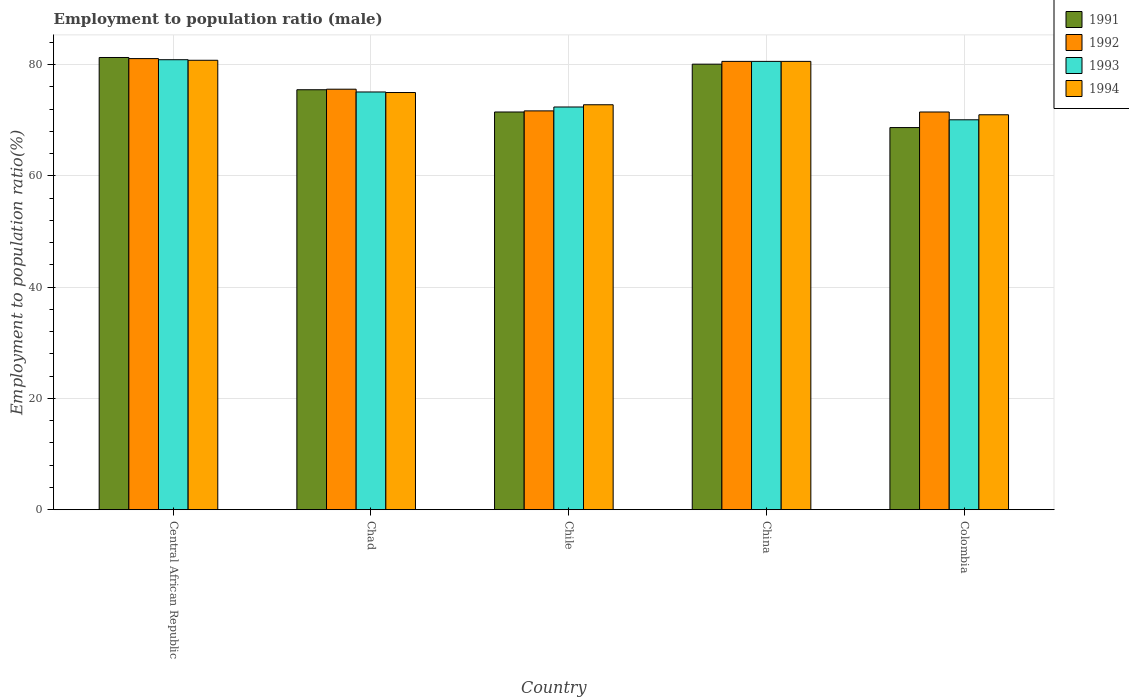Are the number of bars on each tick of the X-axis equal?
Your answer should be compact. Yes. What is the label of the 3rd group of bars from the left?
Your answer should be very brief. Chile. What is the employment to population ratio in 1993 in Central African Republic?
Your answer should be very brief. 80.9. Across all countries, what is the maximum employment to population ratio in 1991?
Make the answer very short. 81.3. Across all countries, what is the minimum employment to population ratio in 1994?
Give a very brief answer. 71. In which country was the employment to population ratio in 1993 maximum?
Your response must be concise. Central African Republic. What is the total employment to population ratio in 1994 in the graph?
Offer a terse response. 380.2. What is the difference between the employment to population ratio in 1994 in Chad and that in Colombia?
Provide a short and direct response. 4. What is the difference between the employment to population ratio in 1994 in Chile and the employment to population ratio in 1992 in Chad?
Your answer should be compact. -2.8. What is the average employment to population ratio in 1994 per country?
Offer a terse response. 76.04. What is the difference between the employment to population ratio of/in 1991 and employment to population ratio of/in 1994 in Chile?
Make the answer very short. -1.3. In how many countries, is the employment to population ratio in 1993 greater than 44 %?
Your answer should be compact. 5. What is the ratio of the employment to population ratio in 1994 in Chile to that in China?
Your answer should be compact. 0.9. Is the employment to population ratio in 1993 in Chad less than that in Colombia?
Make the answer very short. No. Is the difference between the employment to population ratio in 1991 in China and Colombia greater than the difference between the employment to population ratio in 1994 in China and Colombia?
Provide a short and direct response. Yes. What is the difference between the highest and the lowest employment to population ratio in 1993?
Your answer should be compact. 10.8. What does the 1st bar from the left in Colombia represents?
Ensure brevity in your answer.  1991. What does the 3rd bar from the right in Chile represents?
Offer a terse response. 1992. Is it the case that in every country, the sum of the employment to population ratio in 1991 and employment to population ratio in 1994 is greater than the employment to population ratio in 1993?
Provide a short and direct response. Yes. Are the values on the major ticks of Y-axis written in scientific E-notation?
Your response must be concise. No. Does the graph contain grids?
Your answer should be compact. Yes. How many legend labels are there?
Offer a terse response. 4. How are the legend labels stacked?
Offer a terse response. Vertical. What is the title of the graph?
Offer a very short reply. Employment to population ratio (male). Does "1994" appear as one of the legend labels in the graph?
Offer a terse response. Yes. What is the Employment to population ratio(%) of 1991 in Central African Republic?
Ensure brevity in your answer.  81.3. What is the Employment to population ratio(%) in 1992 in Central African Republic?
Offer a terse response. 81.1. What is the Employment to population ratio(%) of 1993 in Central African Republic?
Your response must be concise. 80.9. What is the Employment to population ratio(%) of 1994 in Central African Republic?
Your response must be concise. 80.8. What is the Employment to population ratio(%) of 1991 in Chad?
Provide a short and direct response. 75.5. What is the Employment to population ratio(%) in 1992 in Chad?
Ensure brevity in your answer.  75.6. What is the Employment to population ratio(%) of 1993 in Chad?
Give a very brief answer. 75.1. What is the Employment to population ratio(%) in 1994 in Chad?
Offer a terse response. 75. What is the Employment to population ratio(%) of 1991 in Chile?
Your response must be concise. 71.5. What is the Employment to population ratio(%) in 1992 in Chile?
Offer a very short reply. 71.7. What is the Employment to population ratio(%) in 1993 in Chile?
Offer a very short reply. 72.4. What is the Employment to population ratio(%) of 1994 in Chile?
Ensure brevity in your answer.  72.8. What is the Employment to population ratio(%) in 1991 in China?
Offer a very short reply. 80.1. What is the Employment to population ratio(%) of 1992 in China?
Your answer should be very brief. 80.6. What is the Employment to population ratio(%) of 1993 in China?
Your answer should be compact. 80.6. What is the Employment to population ratio(%) of 1994 in China?
Ensure brevity in your answer.  80.6. What is the Employment to population ratio(%) in 1991 in Colombia?
Your response must be concise. 68.7. What is the Employment to population ratio(%) of 1992 in Colombia?
Your response must be concise. 71.5. What is the Employment to population ratio(%) of 1993 in Colombia?
Make the answer very short. 70.1. What is the Employment to population ratio(%) in 1994 in Colombia?
Ensure brevity in your answer.  71. Across all countries, what is the maximum Employment to population ratio(%) of 1991?
Make the answer very short. 81.3. Across all countries, what is the maximum Employment to population ratio(%) of 1992?
Provide a short and direct response. 81.1. Across all countries, what is the maximum Employment to population ratio(%) in 1993?
Keep it short and to the point. 80.9. Across all countries, what is the maximum Employment to population ratio(%) of 1994?
Ensure brevity in your answer.  80.8. Across all countries, what is the minimum Employment to population ratio(%) in 1991?
Offer a very short reply. 68.7. Across all countries, what is the minimum Employment to population ratio(%) of 1992?
Your answer should be very brief. 71.5. Across all countries, what is the minimum Employment to population ratio(%) of 1993?
Provide a short and direct response. 70.1. Across all countries, what is the minimum Employment to population ratio(%) of 1994?
Your response must be concise. 71. What is the total Employment to population ratio(%) of 1991 in the graph?
Make the answer very short. 377.1. What is the total Employment to population ratio(%) in 1992 in the graph?
Give a very brief answer. 380.5. What is the total Employment to population ratio(%) in 1993 in the graph?
Make the answer very short. 379.1. What is the total Employment to population ratio(%) in 1994 in the graph?
Provide a succinct answer. 380.2. What is the difference between the Employment to population ratio(%) of 1994 in Central African Republic and that in Chad?
Offer a very short reply. 5.8. What is the difference between the Employment to population ratio(%) of 1991 in Central African Republic and that in Chile?
Your answer should be very brief. 9.8. What is the difference between the Employment to population ratio(%) of 1992 in Central African Republic and that in Chile?
Offer a very short reply. 9.4. What is the difference between the Employment to population ratio(%) of 1993 in Central African Republic and that in Chile?
Offer a very short reply. 8.5. What is the difference between the Employment to population ratio(%) in 1991 in Central African Republic and that in China?
Your answer should be very brief. 1.2. What is the difference between the Employment to population ratio(%) of 1991 in Central African Republic and that in Colombia?
Provide a short and direct response. 12.6. What is the difference between the Employment to population ratio(%) in 1994 in Central African Republic and that in Colombia?
Offer a terse response. 9.8. What is the difference between the Employment to population ratio(%) of 1991 in Chad and that in Chile?
Make the answer very short. 4. What is the difference between the Employment to population ratio(%) of 1992 in Chad and that in Chile?
Ensure brevity in your answer.  3.9. What is the difference between the Employment to population ratio(%) in 1991 in Chad and that in China?
Give a very brief answer. -4.6. What is the difference between the Employment to population ratio(%) in 1992 in Chad and that in China?
Your answer should be very brief. -5. What is the difference between the Employment to population ratio(%) of 1991 in Chad and that in Colombia?
Ensure brevity in your answer.  6.8. What is the difference between the Employment to population ratio(%) in 1994 in Chad and that in Colombia?
Provide a short and direct response. 4. What is the difference between the Employment to population ratio(%) of 1991 in Chile and that in China?
Your response must be concise. -8.6. What is the difference between the Employment to population ratio(%) of 1992 in Chile and that in China?
Offer a very short reply. -8.9. What is the difference between the Employment to population ratio(%) of 1993 in Chile and that in China?
Your response must be concise. -8.2. What is the difference between the Employment to population ratio(%) of 1992 in Chile and that in Colombia?
Provide a succinct answer. 0.2. What is the difference between the Employment to population ratio(%) in 1994 in Chile and that in Colombia?
Your answer should be compact. 1.8. What is the difference between the Employment to population ratio(%) in 1991 in China and that in Colombia?
Your response must be concise. 11.4. What is the difference between the Employment to population ratio(%) in 1993 in China and that in Colombia?
Provide a short and direct response. 10.5. What is the difference between the Employment to population ratio(%) in 1991 in Central African Republic and the Employment to population ratio(%) in 1993 in Chad?
Ensure brevity in your answer.  6.2. What is the difference between the Employment to population ratio(%) of 1992 in Central African Republic and the Employment to population ratio(%) of 1994 in Chad?
Your response must be concise. 6.1. What is the difference between the Employment to population ratio(%) in 1991 in Central African Republic and the Employment to population ratio(%) in 1994 in Chile?
Make the answer very short. 8.5. What is the difference between the Employment to population ratio(%) in 1992 in Central African Republic and the Employment to population ratio(%) in 1993 in Chile?
Keep it short and to the point. 8.7. What is the difference between the Employment to population ratio(%) of 1993 in Central African Republic and the Employment to population ratio(%) of 1994 in Chile?
Offer a terse response. 8.1. What is the difference between the Employment to population ratio(%) of 1991 in Central African Republic and the Employment to population ratio(%) of 1992 in China?
Ensure brevity in your answer.  0.7. What is the difference between the Employment to population ratio(%) in 1992 in Central African Republic and the Employment to population ratio(%) in 1994 in China?
Keep it short and to the point. 0.5. What is the difference between the Employment to population ratio(%) of 1991 in Central African Republic and the Employment to population ratio(%) of 1994 in Colombia?
Provide a short and direct response. 10.3. What is the difference between the Employment to population ratio(%) in 1991 in Chad and the Employment to population ratio(%) in 1994 in Chile?
Provide a succinct answer. 2.7. What is the difference between the Employment to population ratio(%) in 1992 in Chad and the Employment to population ratio(%) in 1993 in Chile?
Offer a terse response. 3.2. What is the difference between the Employment to population ratio(%) of 1992 in Chad and the Employment to population ratio(%) of 1994 in Chile?
Keep it short and to the point. 2.8. What is the difference between the Employment to population ratio(%) in 1991 in Chad and the Employment to population ratio(%) in 1993 in China?
Provide a short and direct response. -5.1. What is the difference between the Employment to population ratio(%) of 1991 in Chad and the Employment to population ratio(%) of 1994 in China?
Keep it short and to the point. -5.1. What is the difference between the Employment to population ratio(%) of 1992 in Chad and the Employment to population ratio(%) of 1994 in China?
Ensure brevity in your answer.  -5. What is the difference between the Employment to population ratio(%) in 1993 in Chad and the Employment to population ratio(%) in 1994 in China?
Keep it short and to the point. -5.5. What is the difference between the Employment to population ratio(%) of 1991 in Chad and the Employment to population ratio(%) of 1993 in Colombia?
Your answer should be very brief. 5.4. What is the difference between the Employment to population ratio(%) in 1991 in Chad and the Employment to population ratio(%) in 1994 in Colombia?
Ensure brevity in your answer.  4.5. What is the difference between the Employment to population ratio(%) in 1992 in Chad and the Employment to population ratio(%) in 1994 in Colombia?
Make the answer very short. 4.6. What is the difference between the Employment to population ratio(%) of 1991 in Chile and the Employment to population ratio(%) of 1992 in China?
Your response must be concise. -9.1. What is the difference between the Employment to population ratio(%) in 1993 in Chile and the Employment to population ratio(%) in 1994 in China?
Provide a short and direct response. -8.2. What is the difference between the Employment to population ratio(%) of 1991 in Chile and the Employment to population ratio(%) of 1994 in Colombia?
Keep it short and to the point. 0.5. What is the difference between the Employment to population ratio(%) in 1992 in Chile and the Employment to population ratio(%) in 1993 in Colombia?
Ensure brevity in your answer.  1.6. What is the difference between the Employment to population ratio(%) in 1992 in Chile and the Employment to population ratio(%) in 1994 in Colombia?
Offer a terse response. 0.7. What is the difference between the Employment to population ratio(%) in 1993 in Chile and the Employment to population ratio(%) in 1994 in Colombia?
Ensure brevity in your answer.  1.4. What is the difference between the Employment to population ratio(%) in 1991 in China and the Employment to population ratio(%) in 1992 in Colombia?
Offer a terse response. 8.6. What is the difference between the Employment to population ratio(%) in 1991 in China and the Employment to population ratio(%) in 1993 in Colombia?
Your answer should be very brief. 10. What is the average Employment to population ratio(%) of 1991 per country?
Provide a succinct answer. 75.42. What is the average Employment to population ratio(%) in 1992 per country?
Your answer should be compact. 76.1. What is the average Employment to population ratio(%) of 1993 per country?
Offer a very short reply. 75.82. What is the average Employment to population ratio(%) in 1994 per country?
Give a very brief answer. 76.04. What is the difference between the Employment to population ratio(%) of 1991 and Employment to population ratio(%) of 1992 in Central African Republic?
Offer a very short reply. 0.2. What is the difference between the Employment to population ratio(%) in 1991 and Employment to population ratio(%) in 1993 in Central African Republic?
Your answer should be very brief. 0.4. What is the difference between the Employment to population ratio(%) of 1991 and Employment to population ratio(%) of 1994 in Central African Republic?
Provide a short and direct response. 0.5. What is the difference between the Employment to population ratio(%) of 1991 and Employment to population ratio(%) of 1992 in Chad?
Offer a terse response. -0.1. What is the difference between the Employment to population ratio(%) of 1991 and Employment to population ratio(%) of 1993 in Chad?
Offer a terse response. 0.4. What is the difference between the Employment to population ratio(%) in 1992 and Employment to population ratio(%) in 1994 in Chad?
Ensure brevity in your answer.  0.6. What is the difference between the Employment to population ratio(%) in 1993 and Employment to population ratio(%) in 1994 in Chad?
Your answer should be compact. 0.1. What is the difference between the Employment to population ratio(%) of 1991 and Employment to population ratio(%) of 1992 in Chile?
Provide a succinct answer. -0.2. What is the difference between the Employment to population ratio(%) in 1991 and Employment to population ratio(%) in 1993 in Chile?
Your response must be concise. -0.9. What is the difference between the Employment to population ratio(%) in 1991 and Employment to population ratio(%) in 1994 in Chile?
Keep it short and to the point. -1.3. What is the difference between the Employment to population ratio(%) of 1992 and Employment to population ratio(%) of 1993 in Chile?
Your answer should be compact. -0.7. What is the difference between the Employment to population ratio(%) of 1992 and Employment to population ratio(%) of 1994 in Chile?
Ensure brevity in your answer.  -1.1. What is the difference between the Employment to population ratio(%) in 1993 and Employment to population ratio(%) in 1994 in Chile?
Provide a short and direct response. -0.4. What is the difference between the Employment to population ratio(%) in 1991 and Employment to population ratio(%) in 1992 in China?
Offer a terse response. -0.5. What is the difference between the Employment to population ratio(%) of 1992 and Employment to population ratio(%) of 1993 in China?
Your answer should be compact. 0. What is the difference between the Employment to population ratio(%) of 1992 and Employment to population ratio(%) of 1994 in China?
Offer a very short reply. 0. What is the difference between the Employment to population ratio(%) of 1991 and Employment to population ratio(%) of 1992 in Colombia?
Provide a short and direct response. -2.8. What is the difference between the Employment to population ratio(%) in 1992 and Employment to population ratio(%) in 1993 in Colombia?
Provide a short and direct response. 1.4. What is the difference between the Employment to population ratio(%) of 1992 and Employment to population ratio(%) of 1994 in Colombia?
Offer a terse response. 0.5. What is the ratio of the Employment to population ratio(%) of 1991 in Central African Republic to that in Chad?
Offer a very short reply. 1.08. What is the ratio of the Employment to population ratio(%) of 1992 in Central African Republic to that in Chad?
Provide a succinct answer. 1.07. What is the ratio of the Employment to population ratio(%) of 1993 in Central African Republic to that in Chad?
Make the answer very short. 1.08. What is the ratio of the Employment to population ratio(%) in 1994 in Central African Republic to that in Chad?
Your answer should be compact. 1.08. What is the ratio of the Employment to population ratio(%) of 1991 in Central African Republic to that in Chile?
Offer a very short reply. 1.14. What is the ratio of the Employment to population ratio(%) in 1992 in Central African Republic to that in Chile?
Provide a short and direct response. 1.13. What is the ratio of the Employment to population ratio(%) of 1993 in Central African Republic to that in Chile?
Provide a short and direct response. 1.12. What is the ratio of the Employment to population ratio(%) in 1994 in Central African Republic to that in Chile?
Provide a short and direct response. 1.11. What is the ratio of the Employment to population ratio(%) in 1993 in Central African Republic to that in China?
Your response must be concise. 1. What is the ratio of the Employment to population ratio(%) of 1991 in Central African Republic to that in Colombia?
Keep it short and to the point. 1.18. What is the ratio of the Employment to population ratio(%) of 1992 in Central African Republic to that in Colombia?
Offer a terse response. 1.13. What is the ratio of the Employment to population ratio(%) in 1993 in Central African Republic to that in Colombia?
Your response must be concise. 1.15. What is the ratio of the Employment to population ratio(%) of 1994 in Central African Republic to that in Colombia?
Your answer should be compact. 1.14. What is the ratio of the Employment to population ratio(%) of 1991 in Chad to that in Chile?
Provide a succinct answer. 1.06. What is the ratio of the Employment to population ratio(%) in 1992 in Chad to that in Chile?
Provide a succinct answer. 1.05. What is the ratio of the Employment to population ratio(%) of 1993 in Chad to that in Chile?
Provide a succinct answer. 1.04. What is the ratio of the Employment to population ratio(%) in 1994 in Chad to that in Chile?
Your answer should be compact. 1.03. What is the ratio of the Employment to population ratio(%) of 1991 in Chad to that in China?
Offer a very short reply. 0.94. What is the ratio of the Employment to population ratio(%) of 1992 in Chad to that in China?
Your answer should be compact. 0.94. What is the ratio of the Employment to population ratio(%) of 1993 in Chad to that in China?
Provide a succinct answer. 0.93. What is the ratio of the Employment to population ratio(%) of 1994 in Chad to that in China?
Your answer should be compact. 0.93. What is the ratio of the Employment to population ratio(%) of 1991 in Chad to that in Colombia?
Your answer should be very brief. 1.1. What is the ratio of the Employment to population ratio(%) in 1992 in Chad to that in Colombia?
Offer a very short reply. 1.06. What is the ratio of the Employment to population ratio(%) in 1993 in Chad to that in Colombia?
Offer a very short reply. 1.07. What is the ratio of the Employment to population ratio(%) in 1994 in Chad to that in Colombia?
Ensure brevity in your answer.  1.06. What is the ratio of the Employment to population ratio(%) in 1991 in Chile to that in China?
Ensure brevity in your answer.  0.89. What is the ratio of the Employment to population ratio(%) of 1992 in Chile to that in China?
Offer a very short reply. 0.89. What is the ratio of the Employment to population ratio(%) of 1993 in Chile to that in China?
Your answer should be very brief. 0.9. What is the ratio of the Employment to population ratio(%) of 1994 in Chile to that in China?
Make the answer very short. 0.9. What is the ratio of the Employment to population ratio(%) in 1991 in Chile to that in Colombia?
Provide a short and direct response. 1.04. What is the ratio of the Employment to population ratio(%) in 1992 in Chile to that in Colombia?
Your answer should be compact. 1. What is the ratio of the Employment to population ratio(%) of 1993 in Chile to that in Colombia?
Your answer should be compact. 1.03. What is the ratio of the Employment to population ratio(%) in 1994 in Chile to that in Colombia?
Your answer should be very brief. 1.03. What is the ratio of the Employment to population ratio(%) in 1991 in China to that in Colombia?
Provide a short and direct response. 1.17. What is the ratio of the Employment to population ratio(%) of 1992 in China to that in Colombia?
Your answer should be very brief. 1.13. What is the ratio of the Employment to population ratio(%) in 1993 in China to that in Colombia?
Provide a succinct answer. 1.15. What is the ratio of the Employment to population ratio(%) of 1994 in China to that in Colombia?
Provide a short and direct response. 1.14. What is the difference between the highest and the second highest Employment to population ratio(%) in 1991?
Provide a succinct answer. 1.2. What is the difference between the highest and the second highest Employment to population ratio(%) of 1993?
Offer a terse response. 0.3. What is the difference between the highest and the lowest Employment to population ratio(%) of 1991?
Make the answer very short. 12.6. What is the difference between the highest and the lowest Employment to population ratio(%) of 1993?
Provide a succinct answer. 10.8. 